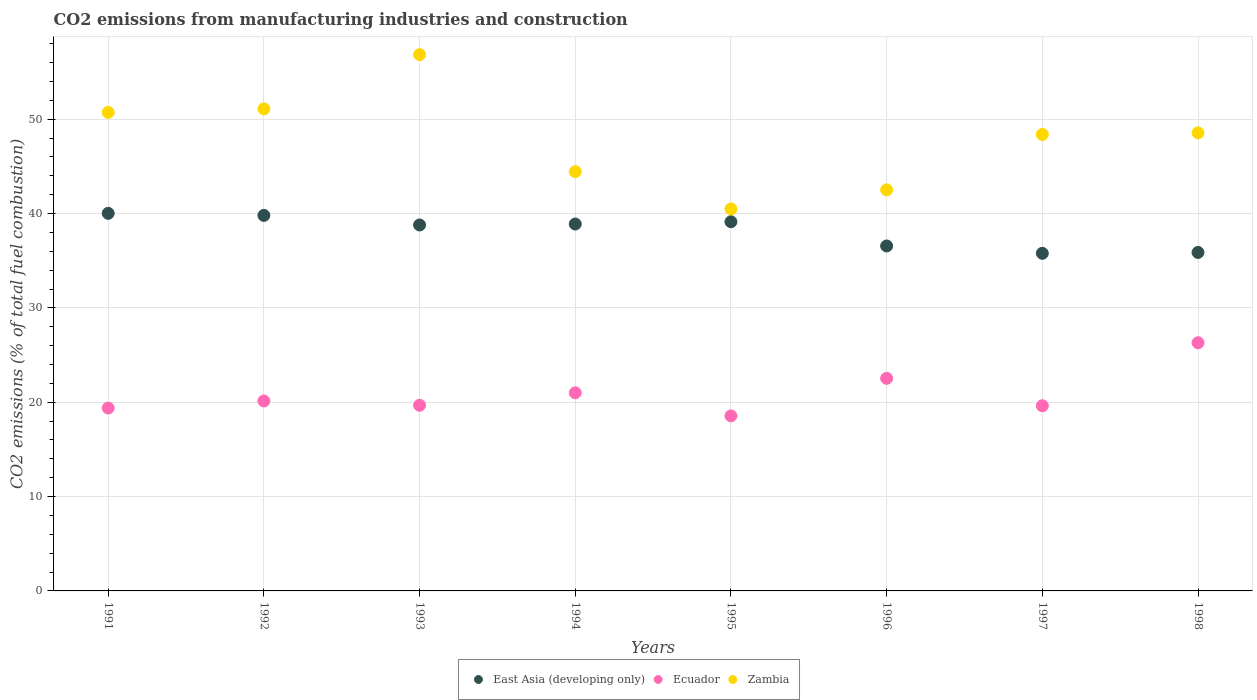What is the amount of CO2 emitted in East Asia (developing only) in 1994?
Provide a succinct answer. 38.89. Across all years, what is the maximum amount of CO2 emitted in East Asia (developing only)?
Offer a very short reply. 40.02. Across all years, what is the minimum amount of CO2 emitted in Zambia?
Keep it short and to the point. 40.49. What is the total amount of CO2 emitted in East Asia (developing only) in the graph?
Make the answer very short. 304.88. What is the difference between the amount of CO2 emitted in East Asia (developing only) in 1996 and that in 1998?
Your answer should be compact. 0.68. What is the difference between the amount of CO2 emitted in Zambia in 1991 and the amount of CO2 emitted in Ecuador in 1996?
Offer a very short reply. 28.19. What is the average amount of CO2 emitted in Ecuador per year?
Keep it short and to the point. 20.9. In the year 1998, what is the difference between the amount of CO2 emitted in Ecuador and amount of CO2 emitted in East Asia (developing only)?
Provide a succinct answer. -9.57. In how many years, is the amount of CO2 emitted in Zambia greater than 18 %?
Your answer should be compact. 8. What is the ratio of the amount of CO2 emitted in Zambia in 1996 to that in 1997?
Ensure brevity in your answer.  0.88. Is the difference between the amount of CO2 emitted in Ecuador in 1996 and 1998 greater than the difference between the amount of CO2 emitted in East Asia (developing only) in 1996 and 1998?
Offer a terse response. No. What is the difference between the highest and the second highest amount of CO2 emitted in Ecuador?
Your response must be concise. 3.78. What is the difference between the highest and the lowest amount of CO2 emitted in Ecuador?
Your response must be concise. 7.75. In how many years, is the amount of CO2 emitted in East Asia (developing only) greater than the average amount of CO2 emitted in East Asia (developing only) taken over all years?
Give a very brief answer. 5. Is the sum of the amount of CO2 emitted in Ecuador in 1993 and 1996 greater than the maximum amount of CO2 emitted in Zambia across all years?
Make the answer very short. No. Does the amount of CO2 emitted in Zambia monotonically increase over the years?
Offer a very short reply. No. Is the amount of CO2 emitted in East Asia (developing only) strictly less than the amount of CO2 emitted in Zambia over the years?
Provide a short and direct response. Yes. Are the values on the major ticks of Y-axis written in scientific E-notation?
Ensure brevity in your answer.  No. What is the title of the graph?
Your answer should be compact. CO2 emissions from manufacturing industries and construction. Does "India" appear as one of the legend labels in the graph?
Make the answer very short. No. What is the label or title of the X-axis?
Offer a terse response. Years. What is the label or title of the Y-axis?
Provide a succinct answer. CO2 emissions (% of total fuel combustion). What is the CO2 emissions (% of total fuel combustion) of East Asia (developing only) in 1991?
Offer a terse response. 40.02. What is the CO2 emissions (% of total fuel combustion) in Ecuador in 1991?
Your answer should be very brief. 19.38. What is the CO2 emissions (% of total fuel combustion) of Zambia in 1991?
Offer a terse response. 50.72. What is the CO2 emissions (% of total fuel combustion) in East Asia (developing only) in 1992?
Make the answer very short. 39.81. What is the CO2 emissions (% of total fuel combustion) in Ecuador in 1992?
Provide a succinct answer. 20.13. What is the CO2 emissions (% of total fuel combustion) of Zambia in 1992?
Your answer should be compact. 51.09. What is the CO2 emissions (% of total fuel combustion) in East Asia (developing only) in 1993?
Offer a terse response. 38.79. What is the CO2 emissions (% of total fuel combustion) in Ecuador in 1993?
Ensure brevity in your answer.  19.68. What is the CO2 emissions (% of total fuel combustion) in Zambia in 1993?
Give a very brief answer. 56.85. What is the CO2 emissions (% of total fuel combustion) in East Asia (developing only) in 1994?
Offer a very short reply. 38.89. What is the CO2 emissions (% of total fuel combustion) in Ecuador in 1994?
Offer a terse response. 21. What is the CO2 emissions (% of total fuel combustion) in Zambia in 1994?
Provide a short and direct response. 44.44. What is the CO2 emissions (% of total fuel combustion) of East Asia (developing only) in 1995?
Give a very brief answer. 39.13. What is the CO2 emissions (% of total fuel combustion) in Ecuador in 1995?
Make the answer very short. 18.56. What is the CO2 emissions (% of total fuel combustion) of Zambia in 1995?
Offer a terse response. 40.49. What is the CO2 emissions (% of total fuel combustion) in East Asia (developing only) in 1996?
Keep it short and to the point. 36.56. What is the CO2 emissions (% of total fuel combustion) in Ecuador in 1996?
Offer a very short reply. 22.53. What is the CO2 emissions (% of total fuel combustion) in Zambia in 1996?
Provide a short and direct response. 42.51. What is the CO2 emissions (% of total fuel combustion) in East Asia (developing only) in 1997?
Offer a very short reply. 35.79. What is the CO2 emissions (% of total fuel combustion) in Ecuador in 1997?
Offer a very short reply. 19.63. What is the CO2 emissions (% of total fuel combustion) of Zambia in 1997?
Offer a terse response. 48.39. What is the CO2 emissions (% of total fuel combustion) of East Asia (developing only) in 1998?
Provide a short and direct response. 35.88. What is the CO2 emissions (% of total fuel combustion) of Ecuador in 1998?
Offer a terse response. 26.31. What is the CO2 emissions (% of total fuel combustion) in Zambia in 1998?
Your answer should be very brief. 48.56. Across all years, what is the maximum CO2 emissions (% of total fuel combustion) of East Asia (developing only)?
Give a very brief answer. 40.02. Across all years, what is the maximum CO2 emissions (% of total fuel combustion) of Ecuador?
Give a very brief answer. 26.31. Across all years, what is the maximum CO2 emissions (% of total fuel combustion) in Zambia?
Keep it short and to the point. 56.85. Across all years, what is the minimum CO2 emissions (% of total fuel combustion) of East Asia (developing only)?
Provide a short and direct response. 35.79. Across all years, what is the minimum CO2 emissions (% of total fuel combustion) of Ecuador?
Provide a succinct answer. 18.56. Across all years, what is the minimum CO2 emissions (% of total fuel combustion) in Zambia?
Your answer should be compact. 40.49. What is the total CO2 emissions (% of total fuel combustion) in East Asia (developing only) in the graph?
Give a very brief answer. 304.88. What is the total CO2 emissions (% of total fuel combustion) of Ecuador in the graph?
Offer a terse response. 167.22. What is the total CO2 emissions (% of total fuel combustion) in Zambia in the graph?
Make the answer very short. 383.06. What is the difference between the CO2 emissions (% of total fuel combustion) of East Asia (developing only) in 1991 and that in 1992?
Provide a succinct answer. 0.22. What is the difference between the CO2 emissions (% of total fuel combustion) in Ecuador in 1991 and that in 1992?
Ensure brevity in your answer.  -0.75. What is the difference between the CO2 emissions (% of total fuel combustion) of Zambia in 1991 and that in 1992?
Your answer should be very brief. -0.37. What is the difference between the CO2 emissions (% of total fuel combustion) in East Asia (developing only) in 1991 and that in 1993?
Ensure brevity in your answer.  1.23. What is the difference between the CO2 emissions (% of total fuel combustion) of Ecuador in 1991 and that in 1993?
Your answer should be compact. -0.29. What is the difference between the CO2 emissions (% of total fuel combustion) in Zambia in 1991 and that in 1993?
Keep it short and to the point. -6.12. What is the difference between the CO2 emissions (% of total fuel combustion) in East Asia (developing only) in 1991 and that in 1994?
Provide a short and direct response. 1.13. What is the difference between the CO2 emissions (% of total fuel combustion) of Ecuador in 1991 and that in 1994?
Your answer should be compact. -1.62. What is the difference between the CO2 emissions (% of total fuel combustion) of Zambia in 1991 and that in 1994?
Your answer should be very brief. 6.28. What is the difference between the CO2 emissions (% of total fuel combustion) of East Asia (developing only) in 1991 and that in 1995?
Offer a very short reply. 0.89. What is the difference between the CO2 emissions (% of total fuel combustion) of Ecuador in 1991 and that in 1995?
Provide a succinct answer. 0.83. What is the difference between the CO2 emissions (% of total fuel combustion) of Zambia in 1991 and that in 1995?
Make the answer very short. 10.24. What is the difference between the CO2 emissions (% of total fuel combustion) in East Asia (developing only) in 1991 and that in 1996?
Ensure brevity in your answer.  3.46. What is the difference between the CO2 emissions (% of total fuel combustion) in Ecuador in 1991 and that in 1996?
Your answer should be very brief. -3.15. What is the difference between the CO2 emissions (% of total fuel combustion) in Zambia in 1991 and that in 1996?
Make the answer very short. 8.21. What is the difference between the CO2 emissions (% of total fuel combustion) in East Asia (developing only) in 1991 and that in 1997?
Make the answer very short. 4.24. What is the difference between the CO2 emissions (% of total fuel combustion) in Ecuador in 1991 and that in 1997?
Make the answer very short. -0.24. What is the difference between the CO2 emissions (% of total fuel combustion) of Zambia in 1991 and that in 1997?
Your response must be concise. 2.34. What is the difference between the CO2 emissions (% of total fuel combustion) in East Asia (developing only) in 1991 and that in 1998?
Offer a terse response. 4.14. What is the difference between the CO2 emissions (% of total fuel combustion) in Ecuador in 1991 and that in 1998?
Keep it short and to the point. -6.92. What is the difference between the CO2 emissions (% of total fuel combustion) in Zambia in 1991 and that in 1998?
Ensure brevity in your answer.  2.17. What is the difference between the CO2 emissions (% of total fuel combustion) in East Asia (developing only) in 1992 and that in 1993?
Provide a succinct answer. 1.01. What is the difference between the CO2 emissions (% of total fuel combustion) in Ecuador in 1992 and that in 1993?
Give a very brief answer. 0.46. What is the difference between the CO2 emissions (% of total fuel combustion) in Zambia in 1992 and that in 1993?
Your answer should be compact. -5.75. What is the difference between the CO2 emissions (% of total fuel combustion) in East Asia (developing only) in 1992 and that in 1994?
Provide a short and direct response. 0.91. What is the difference between the CO2 emissions (% of total fuel combustion) in Ecuador in 1992 and that in 1994?
Give a very brief answer. -0.87. What is the difference between the CO2 emissions (% of total fuel combustion) in Zambia in 1992 and that in 1994?
Offer a very short reply. 6.65. What is the difference between the CO2 emissions (% of total fuel combustion) of East Asia (developing only) in 1992 and that in 1995?
Offer a very short reply. 0.67. What is the difference between the CO2 emissions (% of total fuel combustion) in Ecuador in 1992 and that in 1995?
Your answer should be compact. 1.58. What is the difference between the CO2 emissions (% of total fuel combustion) in Zambia in 1992 and that in 1995?
Give a very brief answer. 10.61. What is the difference between the CO2 emissions (% of total fuel combustion) in East Asia (developing only) in 1992 and that in 1996?
Offer a terse response. 3.24. What is the difference between the CO2 emissions (% of total fuel combustion) in Ecuador in 1992 and that in 1996?
Give a very brief answer. -2.4. What is the difference between the CO2 emissions (% of total fuel combustion) in Zambia in 1992 and that in 1996?
Your answer should be very brief. 8.58. What is the difference between the CO2 emissions (% of total fuel combustion) in East Asia (developing only) in 1992 and that in 1997?
Give a very brief answer. 4.02. What is the difference between the CO2 emissions (% of total fuel combustion) of Ecuador in 1992 and that in 1997?
Provide a succinct answer. 0.51. What is the difference between the CO2 emissions (% of total fuel combustion) of Zambia in 1992 and that in 1997?
Your answer should be very brief. 2.71. What is the difference between the CO2 emissions (% of total fuel combustion) of East Asia (developing only) in 1992 and that in 1998?
Give a very brief answer. 3.93. What is the difference between the CO2 emissions (% of total fuel combustion) in Ecuador in 1992 and that in 1998?
Keep it short and to the point. -6.18. What is the difference between the CO2 emissions (% of total fuel combustion) in Zambia in 1992 and that in 1998?
Keep it short and to the point. 2.54. What is the difference between the CO2 emissions (% of total fuel combustion) of East Asia (developing only) in 1993 and that in 1994?
Your response must be concise. -0.1. What is the difference between the CO2 emissions (% of total fuel combustion) in Ecuador in 1993 and that in 1994?
Offer a very short reply. -1.32. What is the difference between the CO2 emissions (% of total fuel combustion) of Zambia in 1993 and that in 1994?
Your response must be concise. 12.4. What is the difference between the CO2 emissions (% of total fuel combustion) in East Asia (developing only) in 1993 and that in 1995?
Keep it short and to the point. -0.34. What is the difference between the CO2 emissions (% of total fuel combustion) in Ecuador in 1993 and that in 1995?
Ensure brevity in your answer.  1.12. What is the difference between the CO2 emissions (% of total fuel combustion) in Zambia in 1993 and that in 1995?
Keep it short and to the point. 16.36. What is the difference between the CO2 emissions (% of total fuel combustion) of East Asia (developing only) in 1993 and that in 1996?
Your response must be concise. 2.23. What is the difference between the CO2 emissions (% of total fuel combustion) in Ecuador in 1993 and that in 1996?
Keep it short and to the point. -2.86. What is the difference between the CO2 emissions (% of total fuel combustion) in Zambia in 1993 and that in 1996?
Ensure brevity in your answer.  14.33. What is the difference between the CO2 emissions (% of total fuel combustion) of East Asia (developing only) in 1993 and that in 1997?
Offer a very short reply. 3.01. What is the difference between the CO2 emissions (% of total fuel combustion) in Ecuador in 1993 and that in 1997?
Provide a short and direct response. 0.05. What is the difference between the CO2 emissions (% of total fuel combustion) in Zambia in 1993 and that in 1997?
Your answer should be very brief. 8.46. What is the difference between the CO2 emissions (% of total fuel combustion) of East Asia (developing only) in 1993 and that in 1998?
Your answer should be compact. 2.91. What is the difference between the CO2 emissions (% of total fuel combustion) of Ecuador in 1993 and that in 1998?
Ensure brevity in your answer.  -6.63. What is the difference between the CO2 emissions (% of total fuel combustion) of Zambia in 1993 and that in 1998?
Give a very brief answer. 8.29. What is the difference between the CO2 emissions (% of total fuel combustion) of East Asia (developing only) in 1994 and that in 1995?
Give a very brief answer. -0.24. What is the difference between the CO2 emissions (% of total fuel combustion) in Ecuador in 1994 and that in 1995?
Keep it short and to the point. 2.45. What is the difference between the CO2 emissions (% of total fuel combustion) of Zambia in 1994 and that in 1995?
Give a very brief answer. 3.96. What is the difference between the CO2 emissions (% of total fuel combustion) of East Asia (developing only) in 1994 and that in 1996?
Offer a very short reply. 2.33. What is the difference between the CO2 emissions (% of total fuel combustion) of Ecuador in 1994 and that in 1996?
Offer a terse response. -1.53. What is the difference between the CO2 emissions (% of total fuel combustion) in Zambia in 1994 and that in 1996?
Your answer should be very brief. 1.93. What is the difference between the CO2 emissions (% of total fuel combustion) in East Asia (developing only) in 1994 and that in 1997?
Your response must be concise. 3.1. What is the difference between the CO2 emissions (% of total fuel combustion) in Ecuador in 1994 and that in 1997?
Provide a succinct answer. 1.37. What is the difference between the CO2 emissions (% of total fuel combustion) in Zambia in 1994 and that in 1997?
Give a very brief answer. -3.94. What is the difference between the CO2 emissions (% of total fuel combustion) of East Asia (developing only) in 1994 and that in 1998?
Offer a very short reply. 3.01. What is the difference between the CO2 emissions (% of total fuel combustion) in Ecuador in 1994 and that in 1998?
Offer a terse response. -5.31. What is the difference between the CO2 emissions (% of total fuel combustion) in Zambia in 1994 and that in 1998?
Offer a terse response. -4.11. What is the difference between the CO2 emissions (% of total fuel combustion) in East Asia (developing only) in 1995 and that in 1996?
Your answer should be very brief. 2.57. What is the difference between the CO2 emissions (% of total fuel combustion) of Ecuador in 1995 and that in 1996?
Provide a short and direct response. -3.98. What is the difference between the CO2 emissions (% of total fuel combustion) in Zambia in 1995 and that in 1996?
Give a very brief answer. -2.03. What is the difference between the CO2 emissions (% of total fuel combustion) of East Asia (developing only) in 1995 and that in 1997?
Offer a terse response. 3.35. What is the difference between the CO2 emissions (% of total fuel combustion) in Ecuador in 1995 and that in 1997?
Your response must be concise. -1.07. What is the difference between the CO2 emissions (% of total fuel combustion) of Zambia in 1995 and that in 1997?
Ensure brevity in your answer.  -7.9. What is the difference between the CO2 emissions (% of total fuel combustion) of East Asia (developing only) in 1995 and that in 1998?
Offer a terse response. 3.25. What is the difference between the CO2 emissions (% of total fuel combustion) of Ecuador in 1995 and that in 1998?
Your answer should be compact. -7.75. What is the difference between the CO2 emissions (% of total fuel combustion) of Zambia in 1995 and that in 1998?
Offer a terse response. -8.07. What is the difference between the CO2 emissions (% of total fuel combustion) in East Asia (developing only) in 1996 and that in 1997?
Provide a short and direct response. 0.78. What is the difference between the CO2 emissions (% of total fuel combustion) in Ecuador in 1996 and that in 1997?
Your answer should be compact. 2.91. What is the difference between the CO2 emissions (% of total fuel combustion) of Zambia in 1996 and that in 1997?
Your response must be concise. -5.87. What is the difference between the CO2 emissions (% of total fuel combustion) of East Asia (developing only) in 1996 and that in 1998?
Make the answer very short. 0.68. What is the difference between the CO2 emissions (% of total fuel combustion) in Ecuador in 1996 and that in 1998?
Your response must be concise. -3.78. What is the difference between the CO2 emissions (% of total fuel combustion) of Zambia in 1996 and that in 1998?
Ensure brevity in your answer.  -6.04. What is the difference between the CO2 emissions (% of total fuel combustion) in East Asia (developing only) in 1997 and that in 1998?
Provide a short and direct response. -0.09. What is the difference between the CO2 emissions (% of total fuel combustion) in Ecuador in 1997 and that in 1998?
Offer a very short reply. -6.68. What is the difference between the CO2 emissions (% of total fuel combustion) of Zambia in 1997 and that in 1998?
Make the answer very short. -0.17. What is the difference between the CO2 emissions (% of total fuel combustion) in East Asia (developing only) in 1991 and the CO2 emissions (% of total fuel combustion) in Ecuador in 1992?
Your answer should be very brief. 19.89. What is the difference between the CO2 emissions (% of total fuel combustion) of East Asia (developing only) in 1991 and the CO2 emissions (% of total fuel combustion) of Zambia in 1992?
Provide a succinct answer. -11.07. What is the difference between the CO2 emissions (% of total fuel combustion) of Ecuador in 1991 and the CO2 emissions (% of total fuel combustion) of Zambia in 1992?
Offer a terse response. -31.71. What is the difference between the CO2 emissions (% of total fuel combustion) in East Asia (developing only) in 1991 and the CO2 emissions (% of total fuel combustion) in Ecuador in 1993?
Provide a succinct answer. 20.35. What is the difference between the CO2 emissions (% of total fuel combustion) in East Asia (developing only) in 1991 and the CO2 emissions (% of total fuel combustion) in Zambia in 1993?
Ensure brevity in your answer.  -16.82. What is the difference between the CO2 emissions (% of total fuel combustion) in Ecuador in 1991 and the CO2 emissions (% of total fuel combustion) in Zambia in 1993?
Offer a terse response. -37.46. What is the difference between the CO2 emissions (% of total fuel combustion) of East Asia (developing only) in 1991 and the CO2 emissions (% of total fuel combustion) of Ecuador in 1994?
Your answer should be very brief. 19.02. What is the difference between the CO2 emissions (% of total fuel combustion) in East Asia (developing only) in 1991 and the CO2 emissions (% of total fuel combustion) in Zambia in 1994?
Make the answer very short. -4.42. What is the difference between the CO2 emissions (% of total fuel combustion) in Ecuador in 1991 and the CO2 emissions (% of total fuel combustion) in Zambia in 1994?
Make the answer very short. -25.06. What is the difference between the CO2 emissions (% of total fuel combustion) in East Asia (developing only) in 1991 and the CO2 emissions (% of total fuel combustion) in Ecuador in 1995?
Your response must be concise. 21.47. What is the difference between the CO2 emissions (% of total fuel combustion) in East Asia (developing only) in 1991 and the CO2 emissions (% of total fuel combustion) in Zambia in 1995?
Keep it short and to the point. -0.46. What is the difference between the CO2 emissions (% of total fuel combustion) in Ecuador in 1991 and the CO2 emissions (% of total fuel combustion) in Zambia in 1995?
Offer a terse response. -21.1. What is the difference between the CO2 emissions (% of total fuel combustion) of East Asia (developing only) in 1991 and the CO2 emissions (% of total fuel combustion) of Ecuador in 1996?
Provide a succinct answer. 17.49. What is the difference between the CO2 emissions (% of total fuel combustion) in East Asia (developing only) in 1991 and the CO2 emissions (% of total fuel combustion) in Zambia in 1996?
Your response must be concise. -2.49. What is the difference between the CO2 emissions (% of total fuel combustion) in Ecuador in 1991 and the CO2 emissions (% of total fuel combustion) in Zambia in 1996?
Keep it short and to the point. -23.13. What is the difference between the CO2 emissions (% of total fuel combustion) in East Asia (developing only) in 1991 and the CO2 emissions (% of total fuel combustion) in Ecuador in 1997?
Your response must be concise. 20.4. What is the difference between the CO2 emissions (% of total fuel combustion) of East Asia (developing only) in 1991 and the CO2 emissions (% of total fuel combustion) of Zambia in 1997?
Provide a succinct answer. -8.36. What is the difference between the CO2 emissions (% of total fuel combustion) of Ecuador in 1991 and the CO2 emissions (% of total fuel combustion) of Zambia in 1997?
Offer a terse response. -29. What is the difference between the CO2 emissions (% of total fuel combustion) in East Asia (developing only) in 1991 and the CO2 emissions (% of total fuel combustion) in Ecuador in 1998?
Your answer should be very brief. 13.72. What is the difference between the CO2 emissions (% of total fuel combustion) of East Asia (developing only) in 1991 and the CO2 emissions (% of total fuel combustion) of Zambia in 1998?
Your answer should be compact. -8.53. What is the difference between the CO2 emissions (% of total fuel combustion) in Ecuador in 1991 and the CO2 emissions (% of total fuel combustion) in Zambia in 1998?
Provide a short and direct response. -29.17. What is the difference between the CO2 emissions (% of total fuel combustion) of East Asia (developing only) in 1992 and the CO2 emissions (% of total fuel combustion) of Ecuador in 1993?
Your answer should be very brief. 20.13. What is the difference between the CO2 emissions (% of total fuel combustion) in East Asia (developing only) in 1992 and the CO2 emissions (% of total fuel combustion) in Zambia in 1993?
Provide a short and direct response. -17.04. What is the difference between the CO2 emissions (% of total fuel combustion) of Ecuador in 1992 and the CO2 emissions (% of total fuel combustion) of Zambia in 1993?
Offer a terse response. -36.71. What is the difference between the CO2 emissions (% of total fuel combustion) of East Asia (developing only) in 1992 and the CO2 emissions (% of total fuel combustion) of Ecuador in 1994?
Ensure brevity in your answer.  18.8. What is the difference between the CO2 emissions (% of total fuel combustion) in East Asia (developing only) in 1992 and the CO2 emissions (% of total fuel combustion) in Zambia in 1994?
Offer a very short reply. -4.64. What is the difference between the CO2 emissions (% of total fuel combustion) of Ecuador in 1992 and the CO2 emissions (% of total fuel combustion) of Zambia in 1994?
Your response must be concise. -24.31. What is the difference between the CO2 emissions (% of total fuel combustion) of East Asia (developing only) in 1992 and the CO2 emissions (% of total fuel combustion) of Ecuador in 1995?
Your answer should be very brief. 21.25. What is the difference between the CO2 emissions (% of total fuel combustion) in East Asia (developing only) in 1992 and the CO2 emissions (% of total fuel combustion) in Zambia in 1995?
Your answer should be very brief. -0.68. What is the difference between the CO2 emissions (% of total fuel combustion) in Ecuador in 1992 and the CO2 emissions (% of total fuel combustion) in Zambia in 1995?
Ensure brevity in your answer.  -20.35. What is the difference between the CO2 emissions (% of total fuel combustion) in East Asia (developing only) in 1992 and the CO2 emissions (% of total fuel combustion) in Ecuador in 1996?
Give a very brief answer. 17.27. What is the difference between the CO2 emissions (% of total fuel combustion) in East Asia (developing only) in 1992 and the CO2 emissions (% of total fuel combustion) in Zambia in 1996?
Offer a terse response. -2.71. What is the difference between the CO2 emissions (% of total fuel combustion) of Ecuador in 1992 and the CO2 emissions (% of total fuel combustion) of Zambia in 1996?
Your response must be concise. -22.38. What is the difference between the CO2 emissions (% of total fuel combustion) of East Asia (developing only) in 1992 and the CO2 emissions (% of total fuel combustion) of Ecuador in 1997?
Offer a terse response. 20.18. What is the difference between the CO2 emissions (% of total fuel combustion) of East Asia (developing only) in 1992 and the CO2 emissions (% of total fuel combustion) of Zambia in 1997?
Give a very brief answer. -8.58. What is the difference between the CO2 emissions (% of total fuel combustion) in Ecuador in 1992 and the CO2 emissions (% of total fuel combustion) in Zambia in 1997?
Your answer should be compact. -28.25. What is the difference between the CO2 emissions (% of total fuel combustion) of East Asia (developing only) in 1992 and the CO2 emissions (% of total fuel combustion) of Ecuador in 1998?
Keep it short and to the point. 13.5. What is the difference between the CO2 emissions (% of total fuel combustion) of East Asia (developing only) in 1992 and the CO2 emissions (% of total fuel combustion) of Zambia in 1998?
Give a very brief answer. -8.75. What is the difference between the CO2 emissions (% of total fuel combustion) of Ecuador in 1992 and the CO2 emissions (% of total fuel combustion) of Zambia in 1998?
Offer a terse response. -28.42. What is the difference between the CO2 emissions (% of total fuel combustion) of East Asia (developing only) in 1993 and the CO2 emissions (% of total fuel combustion) of Ecuador in 1994?
Give a very brief answer. 17.79. What is the difference between the CO2 emissions (% of total fuel combustion) of East Asia (developing only) in 1993 and the CO2 emissions (% of total fuel combustion) of Zambia in 1994?
Provide a short and direct response. -5.65. What is the difference between the CO2 emissions (% of total fuel combustion) in Ecuador in 1993 and the CO2 emissions (% of total fuel combustion) in Zambia in 1994?
Your answer should be very brief. -24.77. What is the difference between the CO2 emissions (% of total fuel combustion) in East Asia (developing only) in 1993 and the CO2 emissions (% of total fuel combustion) in Ecuador in 1995?
Provide a short and direct response. 20.24. What is the difference between the CO2 emissions (% of total fuel combustion) in East Asia (developing only) in 1993 and the CO2 emissions (% of total fuel combustion) in Zambia in 1995?
Your response must be concise. -1.7. What is the difference between the CO2 emissions (% of total fuel combustion) of Ecuador in 1993 and the CO2 emissions (% of total fuel combustion) of Zambia in 1995?
Make the answer very short. -20.81. What is the difference between the CO2 emissions (% of total fuel combustion) in East Asia (developing only) in 1993 and the CO2 emissions (% of total fuel combustion) in Ecuador in 1996?
Your answer should be very brief. 16.26. What is the difference between the CO2 emissions (% of total fuel combustion) of East Asia (developing only) in 1993 and the CO2 emissions (% of total fuel combustion) of Zambia in 1996?
Provide a short and direct response. -3.72. What is the difference between the CO2 emissions (% of total fuel combustion) of Ecuador in 1993 and the CO2 emissions (% of total fuel combustion) of Zambia in 1996?
Your response must be concise. -22.84. What is the difference between the CO2 emissions (% of total fuel combustion) in East Asia (developing only) in 1993 and the CO2 emissions (% of total fuel combustion) in Ecuador in 1997?
Make the answer very short. 19.17. What is the difference between the CO2 emissions (% of total fuel combustion) in East Asia (developing only) in 1993 and the CO2 emissions (% of total fuel combustion) in Zambia in 1997?
Ensure brevity in your answer.  -9.59. What is the difference between the CO2 emissions (% of total fuel combustion) of Ecuador in 1993 and the CO2 emissions (% of total fuel combustion) of Zambia in 1997?
Give a very brief answer. -28.71. What is the difference between the CO2 emissions (% of total fuel combustion) of East Asia (developing only) in 1993 and the CO2 emissions (% of total fuel combustion) of Ecuador in 1998?
Your answer should be very brief. 12.48. What is the difference between the CO2 emissions (% of total fuel combustion) in East Asia (developing only) in 1993 and the CO2 emissions (% of total fuel combustion) in Zambia in 1998?
Offer a terse response. -9.77. What is the difference between the CO2 emissions (% of total fuel combustion) in Ecuador in 1993 and the CO2 emissions (% of total fuel combustion) in Zambia in 1998?
Your answer should be very brief. -28.88. What is the difference between the CO2 emissions (% of total fuel combustion) in East Asia (developing only) in 1994 and the CO2 emissions (% of total fuel combustion) in Ecuador in 1995?
Provide a succinct answer. 20.34. What is the difference between the CO2 emissions (% of total fuel combustion) in East Asia (developing only) in 1994 and the CO2 emissions (% of total fuel combustion) in Zambia in 1995?
Give a very brief answer. -1.6. What is the difference between the CO2 emissions (% of total fuel combustion) of Ecuador in 1994 and the CO2 emissions (% of total fuel combustion) of Zambia in 1995?
Provide a short and direct response. -19.49. What is the difference between the CO2 emissions (% of total fuel combustion) in East Asia (developing only) in 1994 and the CO2 emissions (% of total fuel combustion) in Ecuador in 1996?
Give a very brief answer. 16.36. What is the difference between the CO2 emissions (% of total fuel combustion) in East Asia (developing only) in 1994 and the CO2 emissions (% of total fuel combustion) in Zambia in 1996?
Provide a succinct answer. -3.62. What is the difference between the CO2 emissions (% of total fuel combustion) of Ecuador in 1994 and the CO2 emissions (% of total fuel combustion) of Zambia in 1996?
Make the answer very short. -21.51. What is the difference between the CO2 emissions (% of total fuel combustion) of East Asia (developing only) in 1994 and the CO2 emissions (% of total fuel combustion) of Ecuador in 1997?
Your answer should be very brief. 19.27. What is the difference between the CO2 emissions (% of total fuel combustion) in East Asia (developing only) in 1994 and the CO2 emissions (% of total fuel combustion) in Zambia in 1997?
Offer a terse response. -9.5. What is the difference between the CO2 emissions (% of total fuel combustion) of Ecuador in 1994 and the CO2 emissions (% of total fuel combustion) of Zambia in 1997?
Provide a short and direct response. -27.39. What is the difference between the CO2 emissions (% of total fuel combustion) of East Asia (developing only) in 1994 and the CO2 emissions (% of total fuel combustion) of Ecuador in 1998?
Provide a short and direct response. 12.58. What is the difference between the CO2 emissions (% of total fuel combustion) of East Asia (developing only) in 1994 and the CO2 emissions (% of total fuel combustion) of Zambia in 1998?
Offer a terse response. -9.67. What is the difference between the CO2 emissions (% of total fuel combustion) in Ecuador in 1994 and the CO2 emissions (% of total fuel combustion) in Zambia in 1998?
Provide a short and direct response. -27.56. What is the difference between the CO2 emissions (% of total fuel combustion) of East Asia (developing only) in 1995 and the CO2 emissions (% of total fuel combustion) of Ecuador in 1996?
Your answer should be compact. 16.6. What is the difference between the CO2 emissions (% of total fuel combustion) in East Asia (developing only) in 1995 and the CO2 emissions (% of total fuel combustion) in Zambia in 1996?
Make the answer very short. -3.38. What is the difference between the CO2 emissions (% of total fuel combustion) in Ecuador in 1995 and the CO2 emissions (% of total fuel combustion) in Zambia in 1996?
Ensure brevity in your answer.  -23.96. What is the difference between the CO2 emissions (% of total fuel combustion) in East Asia (developing only) in 1995 and the CO2 emissions (% of total fuel combustion) in Ecuador in 1997?
Ensure brevity in your answer.  19.51. What is the difference between the CO2 emissions (% of total fuel combustion) of East Asia (developing only) in 1995 and the CO2 emissions (% of total fuel combustion) of Zambia in 1997?
Offer a terse response. -9.25. What is the difference between the CO2 emissions (% of total fuel combustion) in Ecuador in 1995 and the CO2 emissions (% of total fuel combustion) in Zambia in 1997?
Ensure brevity in your answer.  -29.83. What is the difference between the CO2 emissions (% of total fuel combustion) in East Asia (developing only) in 1995 and the CO2 emissions (% of total fuel combustion) in Ecuador in 1998?
Make the answer very short. 12.82. What is the difference between the CO2 emissions (% of total fuel combustion) in East Asia (developing only) in 1995 and the CO2 emissions (% of total fuel combustion) in Zambia in 1998?
Your response must be concise. -9.43. What is the difference between the CO2 emissions (% of total fuel combustion) of Ecuador in 1995 and the CO2 emissions (% of total fuel combustion) of Zambia in 1998?
Offer a terse response. -30. What is the difference between the CO2 emissions (% of total fuel combustion) of East Asia (developing only) in 1996 and the CO2 emissions (% of total fuel combustion) of Ecuador in 1997?
Provide a succinct answer. 16.94. What is the difference between the CO2 emissions (% of total fuel combustion) in East Asia (developing only) in 1996 and the CO2 emissions (% of total fuel combustion) in Zambia in 1997?
Ensure brevity in your answer.  -11.82. What is the difference between the CO2 emissions (% of total fuel combustion) in Ecuador in 1996 and the CO2 emissions (% of total fuel combustion) in Zambia in 1997?
Make the answer very short. -25.85. What is the difference between the CO2 emissions (% of total fuel combustion) of East Asia (developing only) in 1996 and the CO2 emissions (% of total fuel combustion) of Ecuador in 1998?
Offer a terse response. 10.26. What is the difference between the CO2 emissions (% of total fuel combustion) of East Asia (developing only) in 1996 and the CO2 emissions (% of total fuel combustion) of Zambia in 1998?
Provide a succinct answer. -11.99. What is the difference between the CO2 emissions (% of total fuel combustion) in Ecuador in 1996 and the CO2 emissions (% of total fuel combustion) in Zambia in 1998?
Provide a short and direct response. -26.02. What is the difference between the CO2 emissions (% of total fuel combustion) in East Asia (developing only) in 1997 and the CO2 emissions (% of total fuel combustion) in Ecuador in 1998?
Your answer should be very brief. 9.48. What is the difference between the CO2 emissions (% of total fuel combustion) in East Asia (developing only) in 1997 and the CO2 emissions (% of total fuel combustion) in Zambia in 1998?
Your answer should be very brief. -12.77. What is the difference between the CO2 emissions (% of total fuel combustion) of Ecuador in 1997 and the CO2 emissions (% of total fuel combustion) of Zambia in 1998?
Provide a short and direct response. -28.93. What is the average CO2 emissions (% of total fuel combustion) of East Asia (developing only) per year?
Your answer should be compact. 38.11. What is the average CO2 emissions (% of total fuel combustion) of Ecuador per year?
Ensure brevity in your answer.  20.9. What is the average CO2 emissions (% of total fuel combustion) in Zambia per year?
Keep it short and to the point. 47.88. In the year 1991, what is the difference between the CO2 emissions (% of total fuel combustion) in East Asia (developing only) and CO2 emissions (% of total fuel combustion) in Ecuador?
Give a very brief answer. 20.64. In the year 1991, what is the difference between the CO2 emissions (% of total fuel combustion) of East Asia (developing only) and CO2 emissions (% of total fuel combustion) of Zambia?
Offer a terse response. -10.7. In the year 1991, what is the difference between the CO2 emissions (% of total fuel combustion) in Ecuador and CO2 emissions (% of total fuel combustion) in Zambia?
Keep it short and to the point. -31.34. In the year 1992, what is the difference between the CO2 emissions (% of total fuel combustion) in East Asia (developing only) and CO2 emissions (% of total fuel combustion) in Ecuador?
Give a very brief answer. 19.67. In the year 1992, what is the difference between the CO2 emissions (% of total fuel combustion) in East Asia (developing only) and CO2 emissions (% of total fuel combustion) in Zambia?
Ensure brevity in your answer.  -11.29. In the year 1992, what is the difference between the CO2 emissions (% of total fuel combustion) in Ecuador and CO2 emissions (% of total fuel combustion) in Zambia?
Your answer should be compact. -30.96. In the year 1993, what is the difference between the CO2 emissions (% of total fuel combustion) in East Asia (developing only) and CO2 emissions (% of total fuel combustion) in Ecuador?
Provide a succinct answer. 19.12. In the year 1993, what is the difference between the CO2 emissions (% of total fuel combustion) in East Asia (developing only) and CO2 emissions (% of total fuel combustion) in Zambia?
Offer a very short reply. -18.05. In the year 1993, what is the difference between the CO2 emissions (% of total fuel combustion) of Ecuador and CO2 emissions (% of total fuel combustion) of Zambia?
Make the answer very short. -37.17. In the year 1994, what is the difference between the CO2 emissions (% of total fuel combustion) in East Asia (developing only) and CO2 emissions (% of total fuel combustion) in Ecuador?
Your response must be concise. 17.89. In the year 1994, what is the difference between the CO2 emissions (% of total fuel combustion) in East Asia (developing only) and CO2 emissions (% of total fuel combustion) in Zambia?
Keep it short and to the point. -5.55. In the year 1994, what is the difference between the CO2 emissions (% of total fuel combustion) in Ecuador and CO2 emissions (% of total fuel combustion) in Zambia?
Make the answer very short. -23.44. In the year 1995, what is the difference between the CO2 emissions (% of total fuel combustion) in East Asia (developing only) and CO2 emissions (% of total fuel combustion) in Ecuador?
Your answer should be compact. 20.58. In the year 1995, what is the difference between the CO2 emissions (% of total fuel combustion) in East Asia (developing only) and CO2 emissions (% of total fuel combustion) in Zambia?
Make the answer very short. -1.36. In the year 1995, what is the difference between the CO2 emissions (% of total fuel combustion) of Ecuador and CO2 emissions (% of total fuel combustion) of Zambia?
Offer a very short reply. -21.93. In the year 1996, what is the difference between the CO2 emissions (% of total fuel combustion) of East Asia (developing only) and CO2 emissions (% of total fuel combustion) of Ecuador?
Offer a very short reply. 14.03. In the year 1996, what is the difference between the CO2 emissions (% of total fuel combustion) of East Asia (developing only) and CO2 emissions (% of total fuel combustion) of Zambia?
Make the answer very short. -5.95. In the year 1996, what is the difference between the CO2 emissions (% of total fuel combustion) of Ecuador and CO2 emissions (% of total fuel combustion) of Zambia?
Give a very brief answer. -19.98. In the year 1997, what is the difference between the CO2 emissions (% of total fuel combustion) of East Asia (developing only) and CO2 emissions (% of total fuel combustion) of Ecuador?
Give a very brief answer. 16.16. In the year 1997, what is the difference between the CO2 emissions (% of total fuel combustion) in East Asia (developing only) and CO2 emissions (% of total fuel combustion) in Zambia?
Your answer should be very brief. -12.6. In the year 1997, what is the difference between the CO2 emissions (% of total fuel combustion) in Ecuador and CO2 emissions (% of total fuel combustion) in Zambia?
Ensure brevity in your answer.  -28.76. In the year 1998, what is the difference between the CO2 emissions (% of total fuel combustion) in East Asia (developing only) and CO2 emissions (% of total fuel combustion) in Ecuador?
Ensure brevity in your answer.  9.57. In the year 1998, what is the difference between the CO2 emissions (% of total fuel combustion) of East Asia (developing only) and CO2 emissions (% of total fuel combustion) of Zambia?
Your answer should be very brief. -12.68. In the year 1998, what is the difference between the CO2 emissions (% of total fuel combustion) of Ecuador and CO2 emissions (% of total fuel combustion) of Zambia?
Offer a very short reply. -22.25. What is the ratio of the CO2 emissions (% of total fuel combustion) of East Asia (developing only) in 1991 to that in 1992?
Offer a very short reply. 1.01. What is the ratio of the CO2 emissions (% of total fuel combustion) of Ecuador in 1991 to that in 1992?
Offer a very short reply. 0.96. What is the ratio of the CO2 emissions (% of total fuel combustion) of East Asia (developing only) in 1991 to that in 1993?
Keep it short and to the point. 1.03. What is the ratio of the CO2 emissions (% of total fuel combustion) in Ecuador in 1991 to that in 1993?
Your answer should be very brief. 0.99. What is the ratio of the CO2 emissions (% of total fuel combustion) in Zambia in 1991 to that in 1993?
Your response must be concise. 0.89. What is the ratio of the CO2 emissions (% of total fuel combustion) in East Asia (developing only) in 1991 to that in 1994?
Your answer should be compact. 1.03. What is the ratio of the CO2 emissions (% of total fuel combustion) of Zambia in 1991 to that in 1994?
Your answer should be very brief. 1.14. What is the ratio of the CO2 emissions (% of total fuel combustion) in East Asia (developing only) in 1991 to that in 1995?
Give a very brief answer. 1.02. What is the ratio of the CO2 emissions (% of total fuel combustion) in Ecuador in 1991 to that in 1995?
Ensure brevity in your answer.  1.04. What is the ratio of the CO2 emissions (% of total fuel combustion) in Zambia in 1991 to that in 1995?
Ensure brevity in your answer.  1.25. What is the ratio of the CO2 emissions (% of total fuel combustion) in East Asia (developing only) in 1991 to that in 1996?
Your response must be concise. 1.09. What is the ratio of the CO2 emissions (% of total fuel combustion) in Ecuador in 1991 to that in 1996?
Your response must be concise. 0.86. What is the ratio of the CO2 emissions (% of total fuel combustion) of Zambia in 1991 to that in 1996?
Make the answer very short. 1.19. What is the ratio of the CO2 emissions (% of total fuel combustion) of East Asia (developing only) in 1991 to that in 1997?
Your response must be concise. 1.12. What is the ratio of the CO2 emissions (% of total fuel combustion) in Ecuador in 1991 to that in 1997?
Your answer should be compact. 0.99. What is the ratio of the CO2 emissions (% of total fuel combustion) of Zambia in 1991 to that in 1997?
Provide a succinct answer. 1.05. What is the ratio of the CO2 emissions (% of total fuel combustion) of East Asia (developing only) in 1991 to that in 1998?
Ensure brevity in your answer.  1.12. What is the ratio of the CO2 emissions (% of total fuel combustion) of Ecuador in 1991 to that in 1998?
Keep it short and to the point. 0.74. What is the ratio of the CO2 emissions (% of total fuel combustion) in Zambia in 1991 to that in 1998?
Provide a succinct answer. 1.04. What is the ratio of the CO2 emissions (% of total fuel combustion) of East Asia (developing only) in 1992 to that in 1993?
Your answer should be very brief. 1.03. What is the ratio of the CO2 emissions (% of total fuel combustion) in Ecuador in 1992 to that in 1993?
Your answer should be compact. 1.02. What is the ratio of the CO2 emissions (% of total fuel combustion) of Zambia in 1992 to that in 1993?
Your answer should be compact. 0.9. What is the ratio of the CO2 emissions (% of total fuel combustion) in East Asia (developing only) in 1992 to that in 1994?
Offer a very short reply. 1.02. What is the ratio of the CO2 emissions (% of total fuel combustion) of Ecuador in 1992 to that in 1994?
Keep it short and to the point. 0.96. What is the ratio of the CO2 emissions (% of total fuel combustion) of Zambia in 1992 to that in 1994?
Your answer should be very brief. 1.15. What is the ratio of the CO2 emissions (% of total fuel combustion) of East Asia (developing only) in 1992 to that in 1995?
Offer a very short reply. 1.02. What is the ratio of the CO2 emissions (% of total fuel combustion) in Ecuador in 1992 to that in 1995?
Make the answer very short. 1.09. What is the ratio of the CO2 emissions (% of total fuel combustion) of Zambia in 1992 to that in 1995?
Offer a very short reply. 1.26. What is the ratio of the CO2 emissions (% of total fuel combustion) of East Asia (developing only) in 1992 to that in 1996?
Your answer should be very brief. 1.09. What is the ratio of the CO2 emissions (% of total fuel combustion) of Ecuador in 1992 to that in 1996?
Make the answer very short. 0.89. What is the ratio of the CO2 emissions (% of total fuel combustion) of Zambia in 1992 to that in 1996?
Your answer should be compact. 1.2. What is the ratio of the CO2 emissions (% of total fuel combustion) of East Asia (developing only) in 1992 to that in 1997?
Make the answer very short. 1.11. What is the ratio of the CO2 emissions (% of total fuel combustion) in Ecuador in 1992 to that in 1997?
Your answer should be very brief. 1.03. What is the ratio of the CO2 emissions (% of total fuel combustion) of Zambia in 1992 to that in 1997?
Your answer should be compact. 1.06. What is the ratio of the CO2 emissions (% of total fuel combustion) of East Asia (developing only) in 1992 to that in 1998?
Provide a succinct answer. 1.11. What is the ratio of the CO2 emissions (% of total fuel combustion) of Ecuador in 1992 to that in 1998?
Make the answer very short. 0.77. What is the ratio of the CO2 emissions (% of total fuel combustion) in Zambia in 1992 to that in 1998?
Make the answer very short. 1.05. What is the ratio of the CO2 emissions (% of total fuel combustion) in East Asia (developing only) in 1993 to that in 1994?
Your answer should be very brief. 1. What is the ratio of the CO2 emissions (% of total fuel combustion) in Ecuador in 1993 to that in 1994?
Ensure brevity in your answer.  0.94. What is the ratio of the CO2 emissions (% of total fuel combustion) of Zambia in 1993 to that in 1994?
Your response must be concise. 1.28. What is the ratio of the CO2 emissions (% of total fuel combustion) of East Asia (developing only) in 1993 to that in 1995?
Give a very brief answer. 0.99. What is the ratio of the CO2 emissions (% of total fuel combustion) in Ecuador in 1993 to that in 1995?
Offer a terse response. 1.06. What is the ratio of the CO2 emissions (% of total fuel combustion) in Zambia in 1993 to that in 1995?
Provide a short and direct response. 1.4. What is the ratio of the CO2 emissions (% of total fuel combustion) in East Asia (developing only) in 1993 to that in 1996?
Your answer should be very brief. 1.06. What is the ratio of the CO2 emissions (% of total fuel combustion) in Ecuador in 1993 to that in 1996?
Ensure brevity in your answer.  0.87. What is the ratio of the CO2 emissions (% of total fuel combustion) of Zambia in 1993 to that in 1996?
Ensure brevity in your answer.  1.34. What is the ratio of the CO2 emissions (% of total fuel combustion) in East Asia (developing only) in 1993 to that in 1997?
Offer a very short reply. 1.08. What is the ratio of the CO2 emissions (% of total fuel combustion) of Ecuador in 1993 to that in 1997?
Offer a very short reply. 1. What is the ratio of the CO2 emissions (% of total fuel combustion) of Zambia in 1993 to that in 1997?
Provide a succinct answer. 1.17. What is the ratio of the CO2 emissions (% of total fuel combustion) of East Asia (developing only) in 1993 to that in 1998?
Provide a short and direct response. 1.08. What is the ratio of the CO2 emissions (% of total fuel combustion) in Ecuador in 1993 to that in 1998?
Your answer should be compact. 0.75. What is the ratio of the CO2 emissions (% of total fuel combustion) of Zambia in 1993 to that in 1998?
Your answer should be very brief. 1.17. What is the ratio of the CO2 emissions (% of total fuel combustion) in East Asia (developing only) in 1994 to that in 1995?
Give a very brief answer. 0.99. What is the ratio of the CO2 emissions (% of total fuel combustion) of Ecuador in 1994 to that in 1995?
Provide a succinct answer. 1.13. What is the ratio of the CO2 emissions (% of total fuel combustion) of Zambia in 1994 to that in 1995?
Offer a terse response. 1.1. What is the ratio of the CO2 emissions (% of total fuel combustion) in East Asia (developing only) in 1994 to that in 1996?
Provide a succinct answer. 1.06. What is the ratio of the CO2 emissions (% of total fuel combustion) of Ecuador in 1994 to that in 1996?
Your response must be concise. 0.93. What is the ratio of the CO2 emissions (% of total fuel combustion) in Zambia in 1994 to that in 1996?
Your answer should be very brief. 1.05. What is the ratio of the CO2 emissions (% of total fuel combustion) in East Asia (developing only) in 1994 to that in 1997?
Your answer should be very brief. 1.09. What is the ratio of the CO2 emissions (% of total fuel combustion) of Ecuador in 1994 to that in 1997?
Offer a terse response. 1.07. What is the ratio of the CO2 emissions (% of total fuel combustion) in Zambia in 1994 to that in 1997?
Ensure brevity in your answer.  0.92. What is the ratio of the CO2 emissions (% of total fuel combustion) in East Asia (developing only) in 1994 to that in 1998?
Your answer should be compact. 1.08. What is the ratio of the CO2 emissions (% of total fuel combustion) of Ecuador in 1994 to that in 1998?
Keep it short and to the point. 0.8. What is the ratio of the CO2 emissions (% of total fuel combustion) in Zambia in 1994 to that in 1998?
Your answer should be compact. 0.92. What is the ratio of the CO2 emissions (% of total fuel combustion) in East Asia (developing only) in 1995 to that in 1996?
Provide a succinct answer. 1.07. What is the ratio of the CO2 emissions (% of total fuel combustion) in Ecuador in 1995 to that in 1996?
Provide a succinct answer. 0.82. What is the ratio of the CO2 emissions (% of total fuel combustion) in Zambia in 1995 to that in 1996?
Make the answer very short. 0.95. What is the ratio of the CO2 emissions (% of total fuel combustion) of East Asia (developing only) in 1995 to that in 1997?
Keep it short and to the point. 1.09. What is the ratio of the CO2 emissions (% of total fuel combustion) of Ecuador in 1995 to that in 1997?
Offer a very short reply. 0.95. What is the ratio of the CO2 emissions (% of total fuel combustion) in Zambia in 1995 to that in 1997?
Give a very brief answer. 0.84. What is the ratio of the CO2 emissions (% of total fuel combustion) in East Asia (developing only) in 1995 to that in 1998?
Provide a short and direct response. 1.09. What is the ratio of the CO2 emissions (% of total fuel combustion) of Ecuador in 1995 to that in 1998?
Your answer should be very brief. 0.71. What is the ratio of the CO2 emissions (% of total fuel combustion) in Zambia in 1995 to that in 1998?
Give a very brief answer. 0.83. What is the ratio of the CO2 emissions (% of total fuel combustion) of East Asia (developing only) in 1996 to that in 1997?
Provide a short and direct response. 1.02. What is the ratio of the CO2 emissions (% of total fuel combustion) of Ecuador in 1996 to that in 1997?
Offer a very short reply. 1.15. What is the ratio of the CO2 emissions (% of total fuel combustion) of Zambia in 1996 to that in 1997?
Offer a very short reply. 0.88. What is the ratio of the CO2 emissions (% of total fuel combustion) of East Asia (developing only) in 1996 to that in 1998?
Keep it short and to the point. 1.02. What is the ratio of the CO2 emissions (% of total fuel combustion) in Ecuador in 1996 to that in 1998?
Your answer should be compact. 0.86. What is the ratio of the CO2 emissions (% of total fuel combustion) in Zambia in 1996 to that in 1998?
Your answer should be very brief. 0.88. What is the ratio of the CO2 emissions (% of total fuel combustion) of Ecuador in 1997 to that in 1998?
Offer a very short reply. 0.75. What is the ratio of the CO2 emissions (% of total fuel combustion) in Zambia in 1997 to that in 1998?
Make the answer very short. 1. What is the difference between the highest and the second highest CO2 emissions (% of total fuel combustion) in East Asia (developing only)?
Your answer should be very brief. 0.22. What is the difference between the highest and the second highest CO2 emissions (% of total fuel combustion) in Ecuador?
Keep it short and to the point. 3.78. What is the difference between the highest and the second highest CO2 emissions (% of total fuel combustion) of Zambia?
Your answer should be compact. 5.75. What is the difference between the highest and the lowest CO2 emissions (% of total fuel combustion) in East Asia (developing only)?
Your answer should be very brief. 4.24. What is the difference between the highest and the lowest CO2 emissions (% of total fuel combustion) in Ecuador?
Ensure brevity in your answer.  7.75. What is the difference between the highest and the lowest CO2 emissions (% of total fuel combustion) in Zambia?
Your response must be concise. 16.36. 